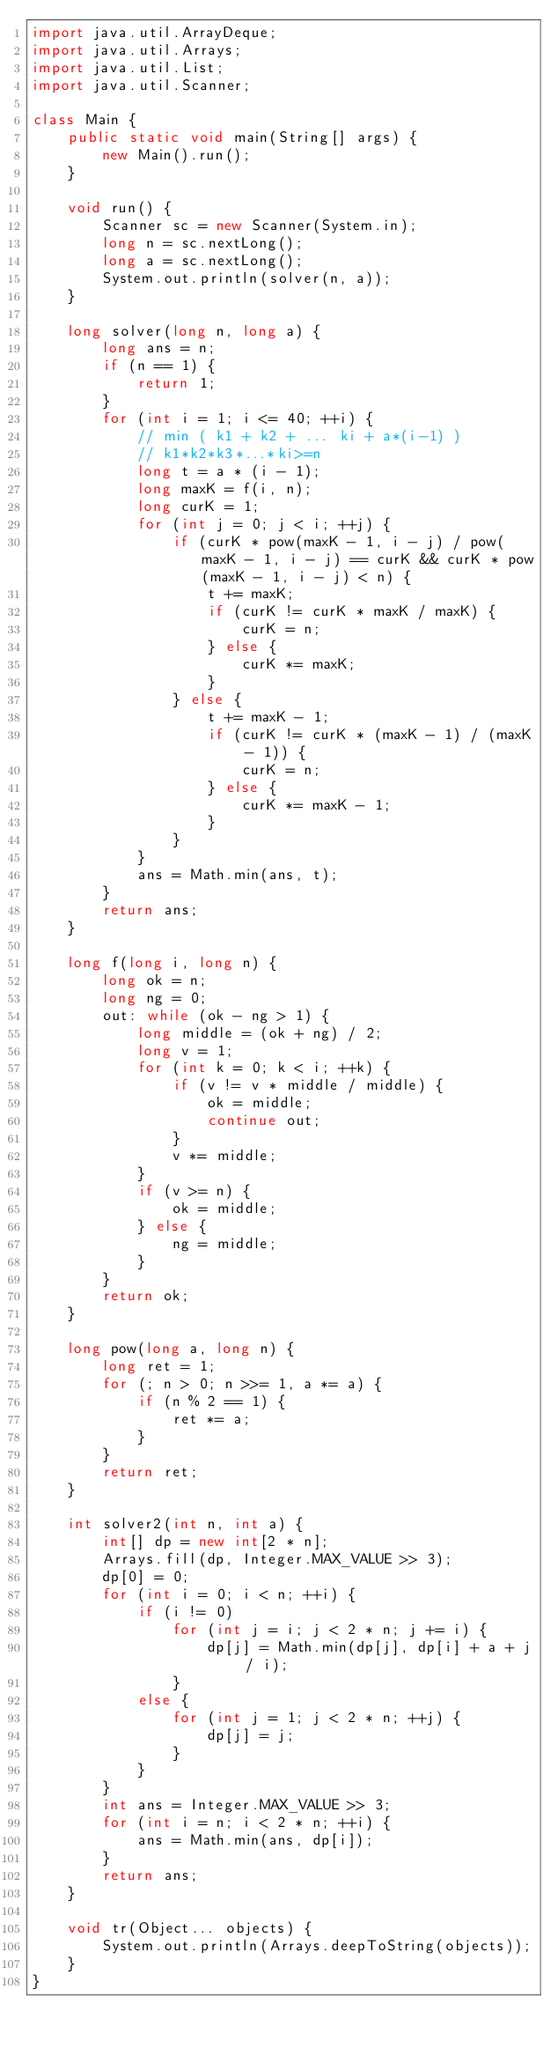Convert code to text. <code><loc_0><loc_0><loc_500><loc_500><_Java_>import java.util.ArrayDeque;
import java.util.Arrays;
import java.util.List;
import java.util.Scanner;

class Main {
	public static void main(String[] args) {
		new Main().run();
	}

	void run() {
		Scanner sc = new Scanner(System.in);
		long n = sc.nextLong();
		long a = sc.nextLong();
		System.out.println(solver(n, a));
	}

	long solver(long n, long a) {
		long ans = n;
		if (n == 1) {
			return 1;
		}
		for (int i = 1; i <= 40; ++i) {
			// min ( k1 + k2 + ... ki + a*(i-1) )
			// k1*k2*k3*...*ki>=n
			long t = a * (i - 1);
			long maxK = f(i, n);
			long curK = 1;
			for (int j = 0; j < i; ++j) {
				if (curK * pow(maxK - 1, i - j) / pow(maxK - 1, i - j) == curK && curK * pow(maxK - 1, i - j) < n) {
					t += maxK;
					if (curK != curK * maxK / maxK) {
						curK = n;
					} else {
						curK *= maxK;
					}
				} else {
					t += maxK - 1;
					if (curK != curK * (maxK - 1) / (maxK - 1)) {
						curK = n;
					} else {
						curK *= maxK - 1;
					}
				}
			}
			ans = Math.min(ans, t);
		}
		return ans;
	}

	long f(long i, long n) {
		long ok = n;
		long ng = 0;
		out: while (ok - ng > 1) {
			long middle = (ok + ng) / 2;
			long v = 1;
			for (int k = 0; k < i; ++k) {
				if (v != v * middle / middle) {
					ok = middle;
					continue out;
				}
				v *= middle;
			}
			if (v >= n) {
				ok = middle;
			} else {
				ng = middle;
			}
		}
		return ok;
	}

	long pow(long a, long n) {
		long ret = 1;
		for (; n > 0; n >>= 1, a *= a) {
			if (n % 2 == 1) {
				ret *= a;
			}
		}
		return ret;
	}

	int solver2(int n, int a) {
		int[] dp = new int[2 * n];
		Arrays.fill(dp, Integer.MAX_VALUE >> 3);
		dp[0] = 0;
		for (int i = 0; i < n; ++i) {
			if (i != 0)
				for (int j = i; j < 2 * n; j += i) {
					dp[j] = Math.min(dp[j], dp[i] + a + j / i);
				}
			else {
				for (int j = 1; j < 2 * n; ++j) {
					dp[j] = j;
				}
			}
		}
		int ans = Integer.MAX_VALUE >> 3;
		for (int i = n; i < 2 * n; ++i) {
			ans = Math.min(ans, dp[i]);
		}
		return ans;
	}

	void tr(Object... objects) {
		System.out.println(Arrays.deepToString(objects));
	}
}</code> 